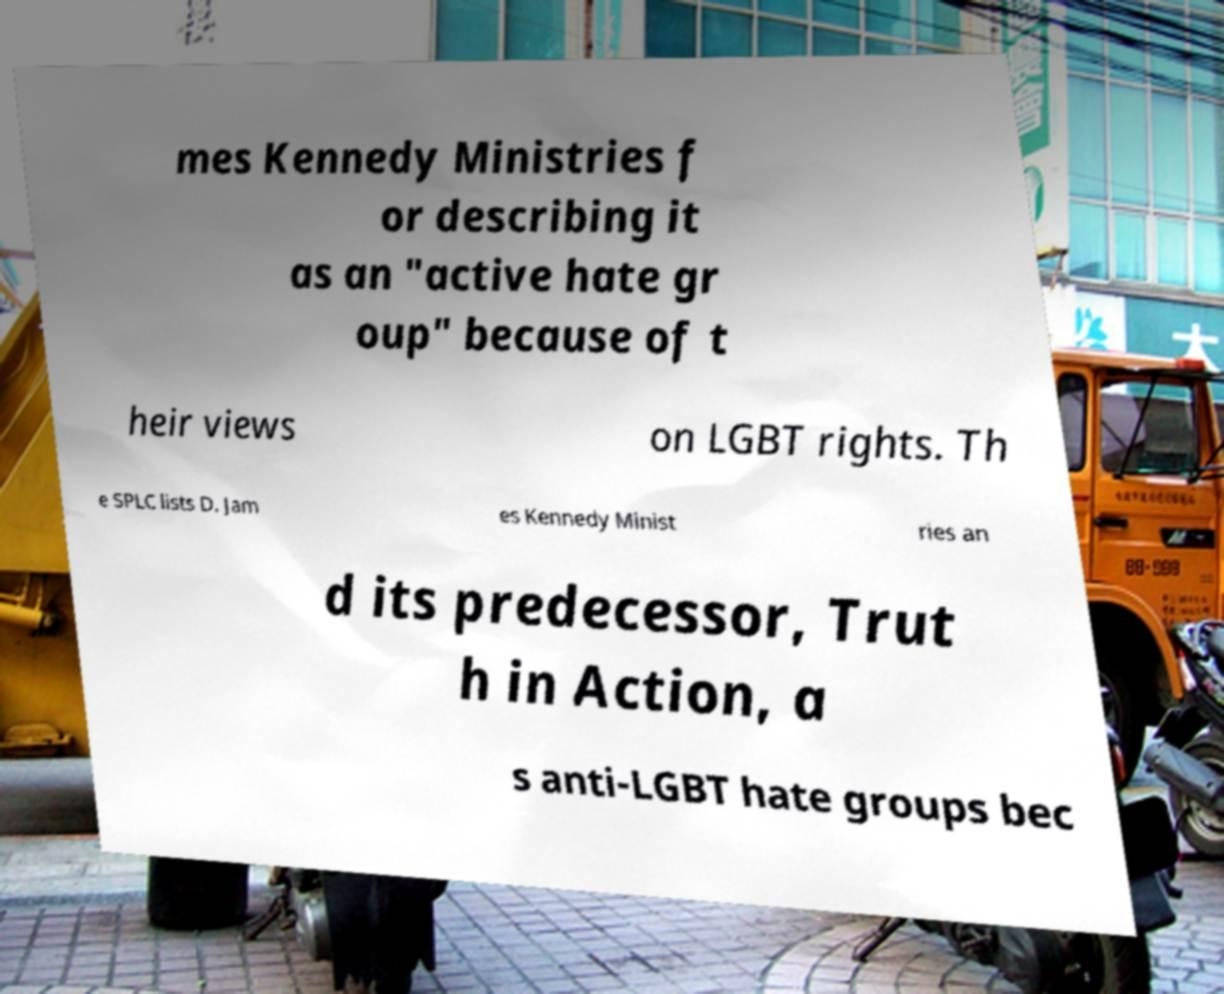Could you extract and type out the text from this image? mes Kennedy Ministries f or describing it as an "active hate gr oup" because of t heir views on LGBT rights. Th e SPLC lists D. Jam es Kennedy Minist ries an d its predecessor, Trut h in Action, a s anti-LGBT hate groups bec 